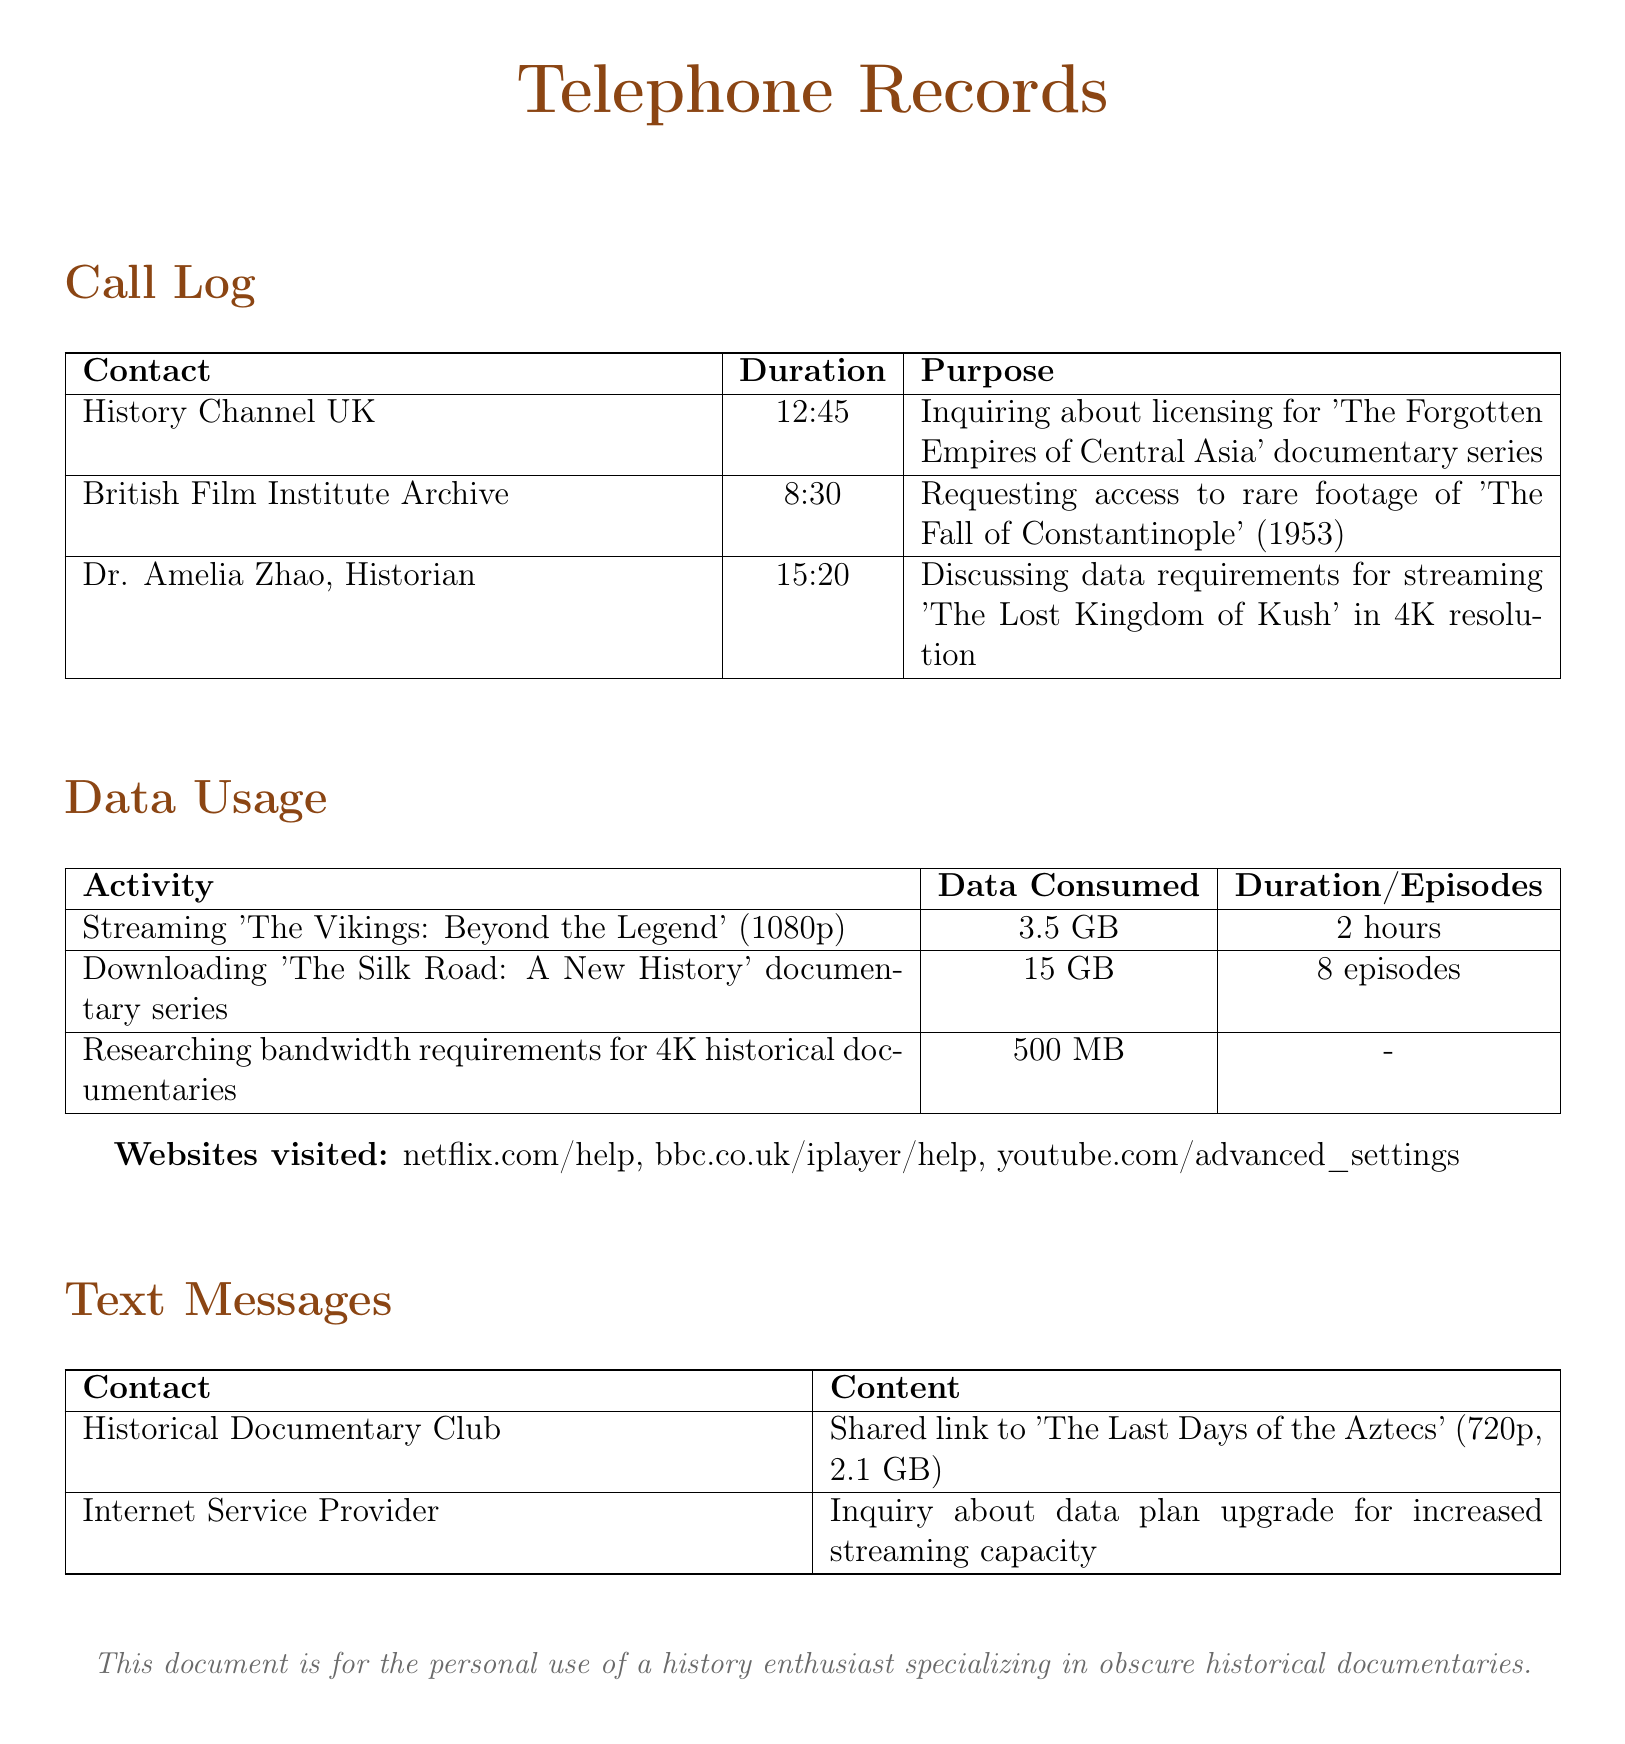What is the duration of the call to Dr. Amelia Zhao? The call duration is listed in the Call Log next to Dr. Amelia Zhao's name, which is 15:20.
Answer: 15:20 How much data was consumed while streaming 'The Vikings: Beyond the Legend'? The data consumed for this streaming activity is specified in the Data Usage section as 3.5 GB.
Answer: 3.5 GB Which documentary was downloaded and how many episodes does it have? The document lists the downloaded documentary and its episode count in the Data Usage section: 'The Silk Road: A New History' with 8 episodes.
Answer: 'The Silk Road: A New History', 8 episodes What was the purpose of the call to the British Film Institute Archive? The purpose of the call is documented in the Call Log, specifically requesting access to rare footage of 'The Fall of Constantinople' (1953).
Answer: Requesting access to rare footage of 'The Fall of Constantinople' (1953) What website was visited for seeking help with Netflix? The document mentions the website visited for help, which is listed in the Websites visited section as netflix.com/help.
Answer: netflix.com/help How much data was used for researching bandwidth requirements? The amount of data consumed for this research is indicated in the Data Usage section as 500 MB.
Answer: 500 MB What type of message was received from the Historical Documentary Club? The document contains a record of a text message where the Historical Documentary Club shared a link, which is mentioned in the Text Messages section.
Answer: Shared link to 'The Last Days of the Aztecs' (720p, 2.1 GB) How long is the documentary 'The Lost Kingdom of Kush'? The document does not specify the length of 'The Lost Kingdom of Kush'; it only discusses data requirements for streaming it in 4K resolution.
Answer: Not specified 